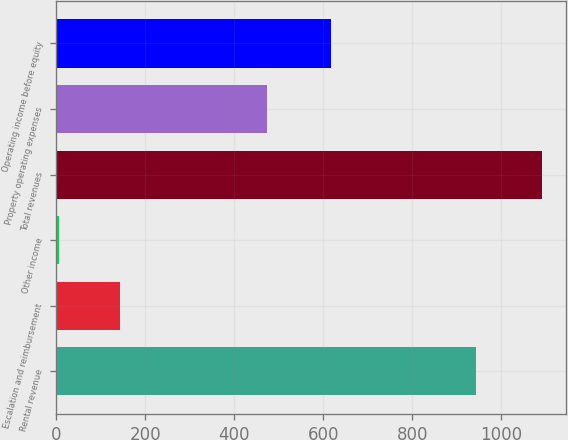Convert chart to OTSL. <chart><loc_0><loc_0><loc_500><loc_500><bar_chart><fcel>Rental revenue<fcel>Escalation and reimbursement<fcel>Other income<fcel>Total revenues<fcel>Property operating expenses<fcel>Operating income before equity<nl><fcel>942.6<fcel>142<fcel>6.8<fcel>1091.4<fcel>474.2<fcel>617.2<nl></chart> 